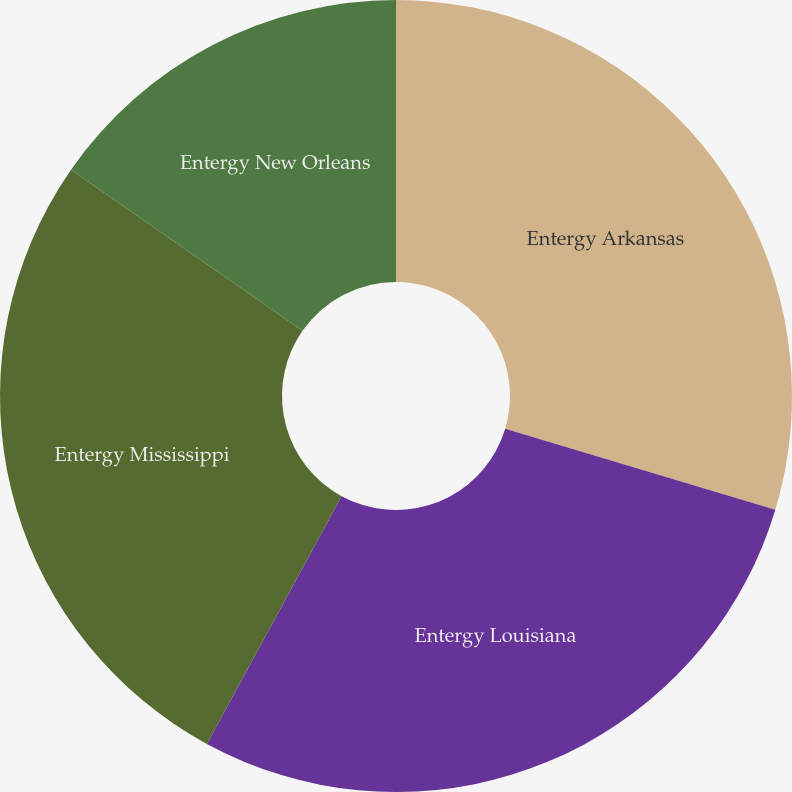<chart> <loc_0><loc_0><loc_500><loc_500><pie_chart><fcel>Entergy Arkansas<fcel>Entergy Louisiana<fcel>Entergy Mississippi<fcel>Entergy New Orleans<nl><fcel>29.64%<fcel>28.29%<fcel>26.76%<fcel>15.32%<nl></chart> 